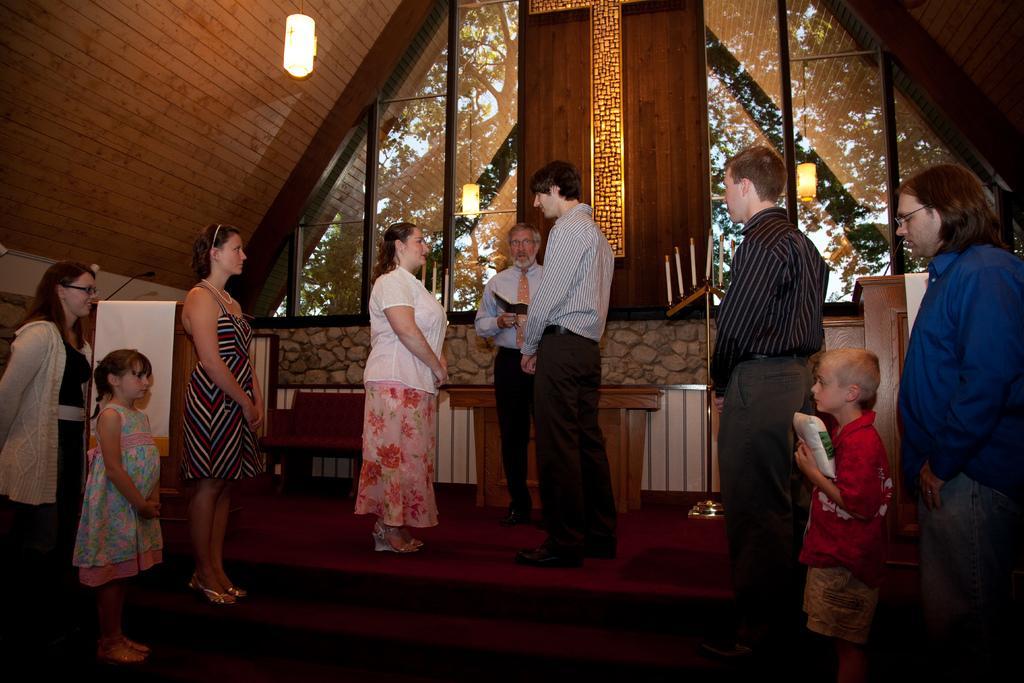Describe this image in one or two sentences. In this image we can see some people standing on the floor. We can also see a man holding a book. On the right side we can see a child holding a cover. On the backside we can see a roof, ceiling lights, glass, candles to a stand, mic and a wall. 